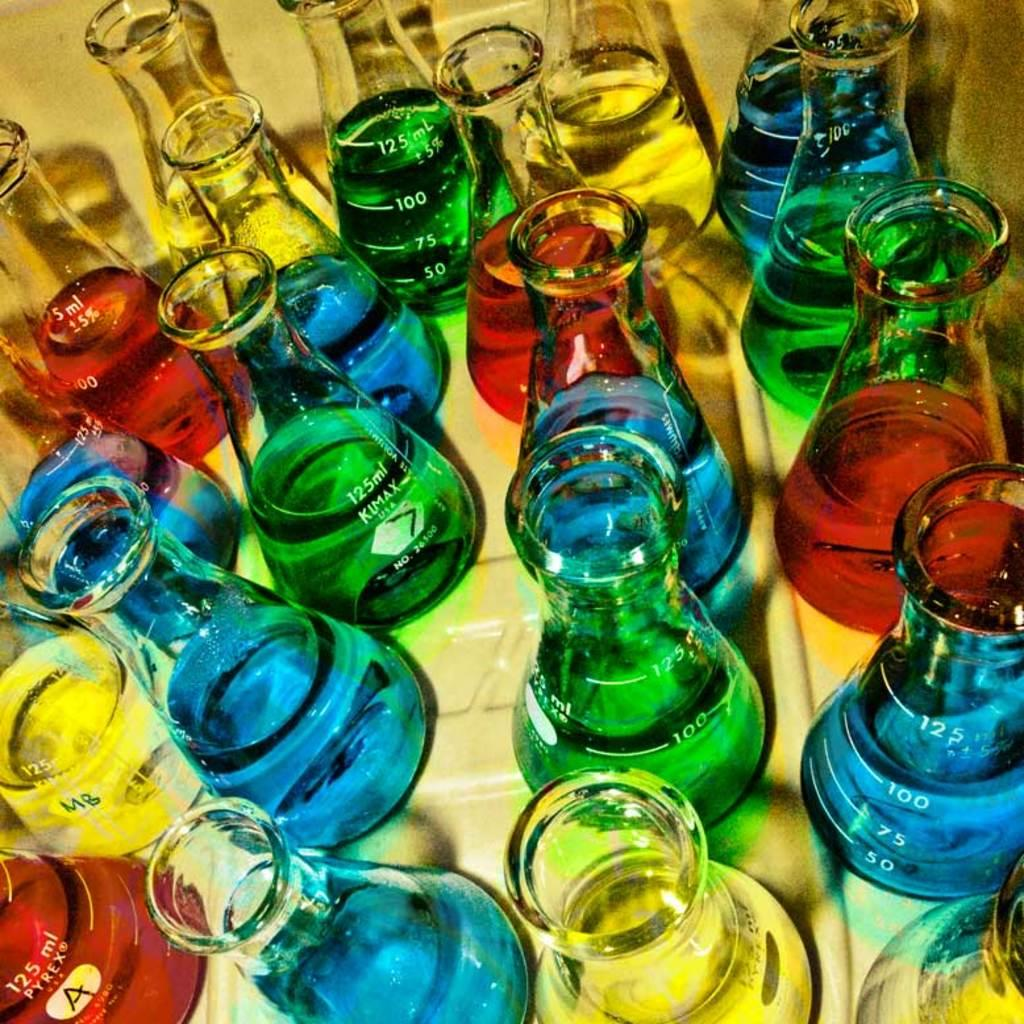What type of containers are present in the image? There are conical flasks in the image. What is inside the conical flasks? The conical flasks contain different colored liquids. What type of plants can be seen growing in the conical flasks? There are no plants visible in the conical flasks; they contain different colored liquids. Can you tell me how many basketballs are present in the image? There are no basketballs present in the image; it features conical flasks with colored liquids. 